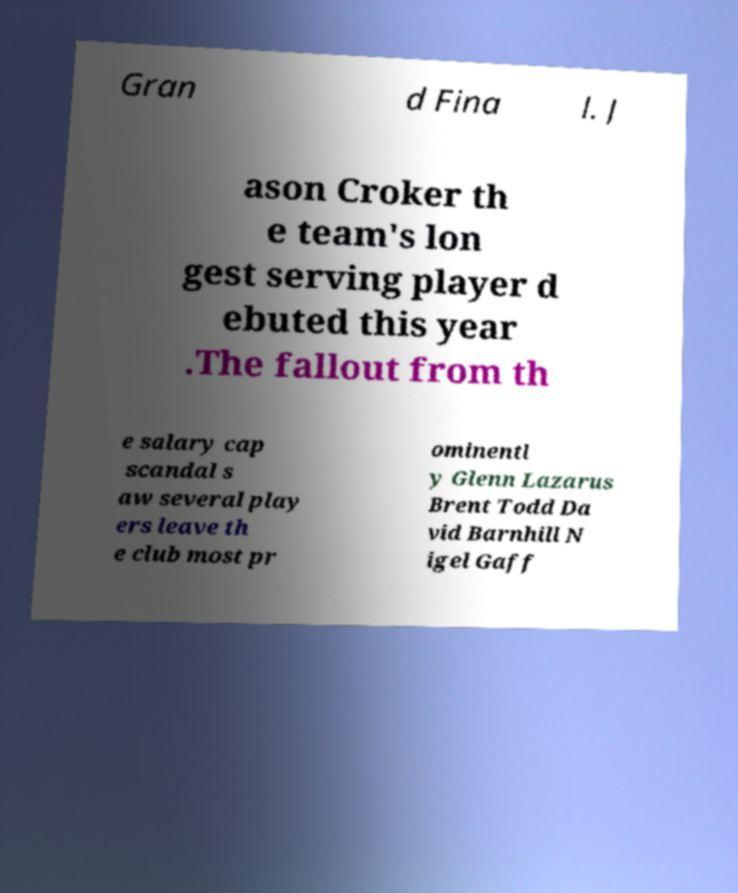Please identify and transcribe the text found in this image. Gran d Fina l. J ason Croker th e team's lon gest serving player d ebuted this year .The fallout from th e salary cap scandal s aw several play ers leave th e club most pr ominentl y Glenn Lazarus Brent Todd Da vid Barnhill N igel Gaff 